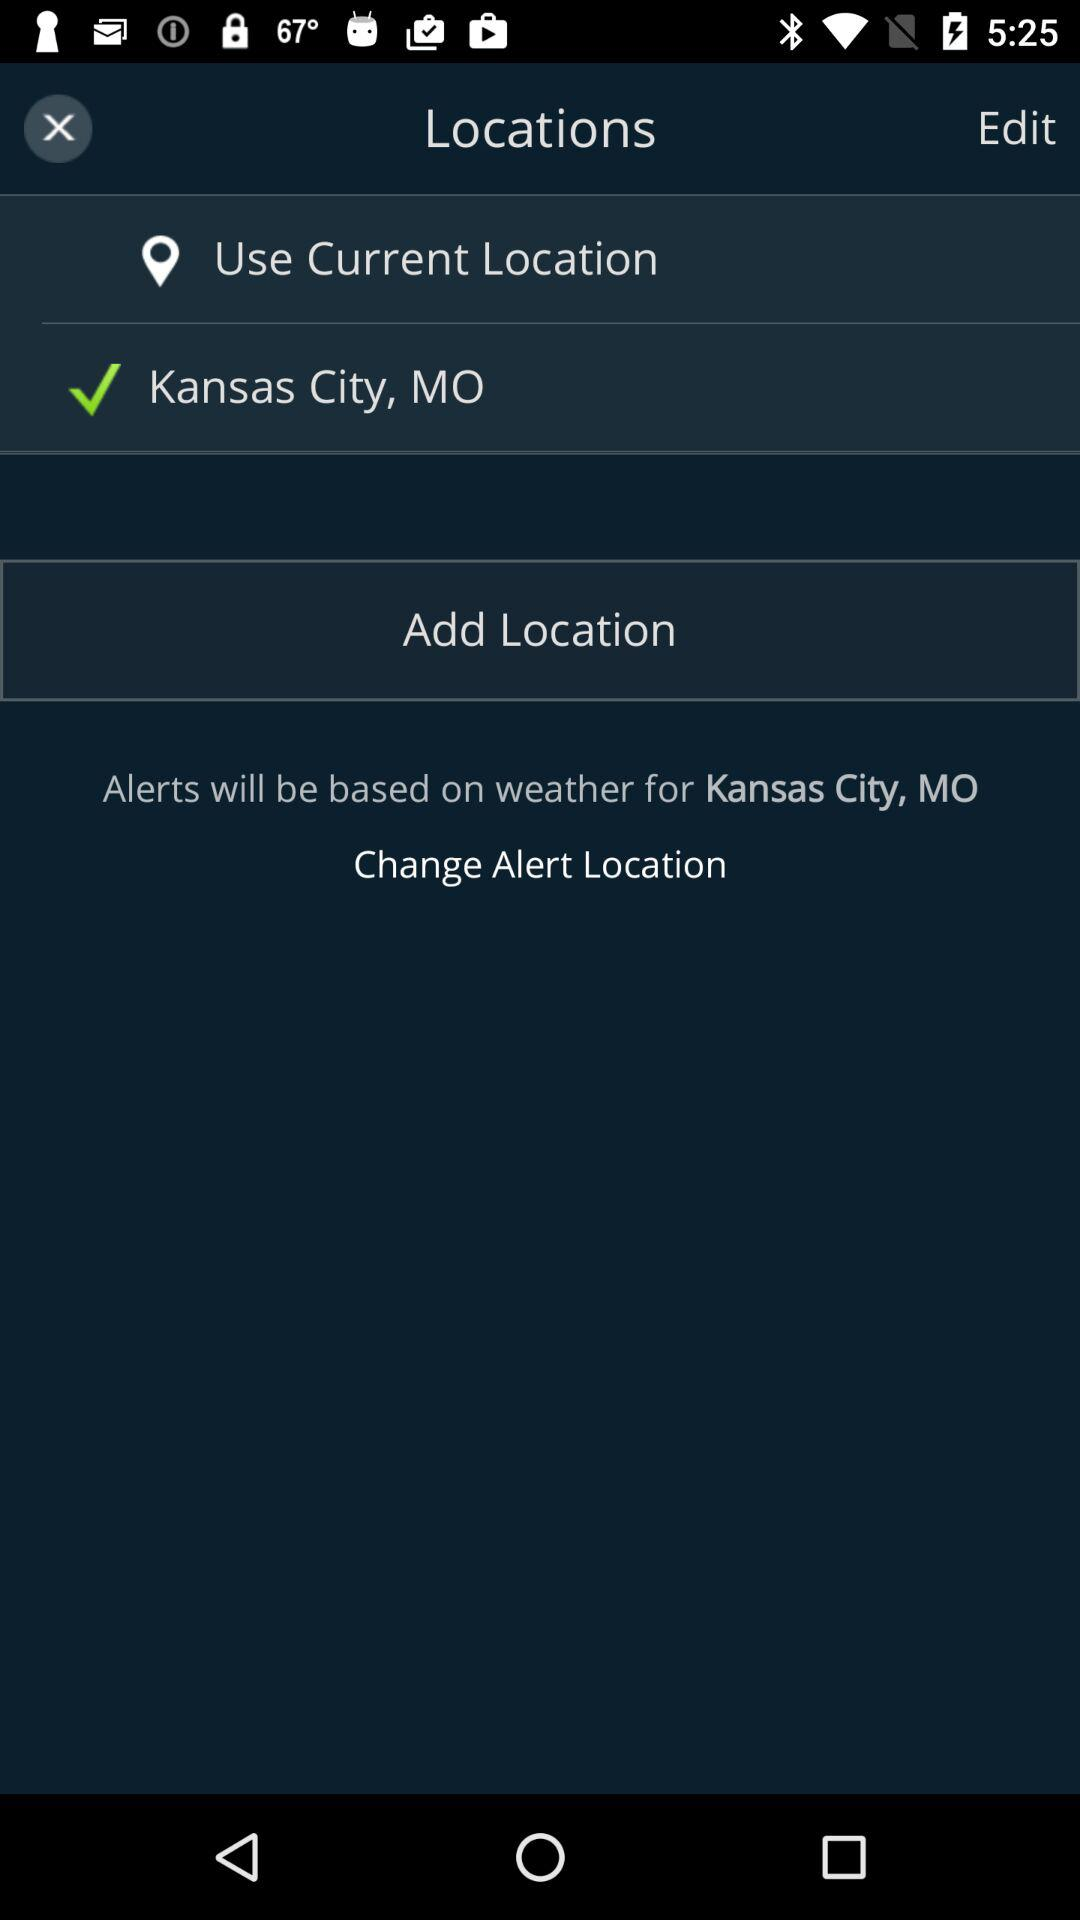What is the username?
When the provided information is insufficient, respond with <no answer>. <no answer> 